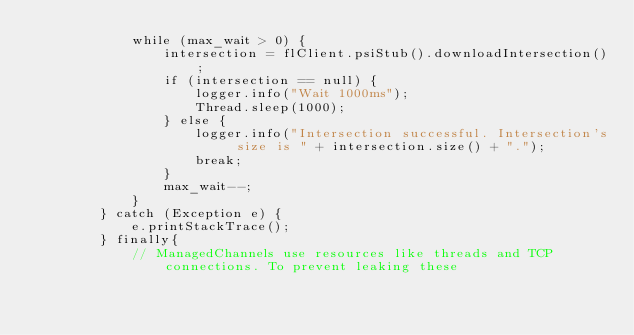Convert code to text. <code><loc_0><loc_0><loc_500><loc_500><_Java_>            while (max_wait > 0) {
                intersection = flClient.psiStub().downloadIntersection();
                if (intersection == null) {
                    logger.info("Wait 1000ms");
                    Thread.sleep(1000);
                } else {
                    logger.info("Intersection successful. Intersection's size is " + intersection.size() + ".");
                    break;
                }
                max_wait--;
            }
        } catch (Exception e) {
            e.printStackTrace();
        } finally{
            // ManagedChannels use resources like threads and TCP connections. To prevent leaking these</code> 